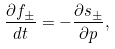<formula> <loc_0><loc_0><loc_500><loc_500>\frac { \partial f _ { \pm } } { d t } = - \frac { \partial s _ { \pm } } { \partial p } ,</formula> 